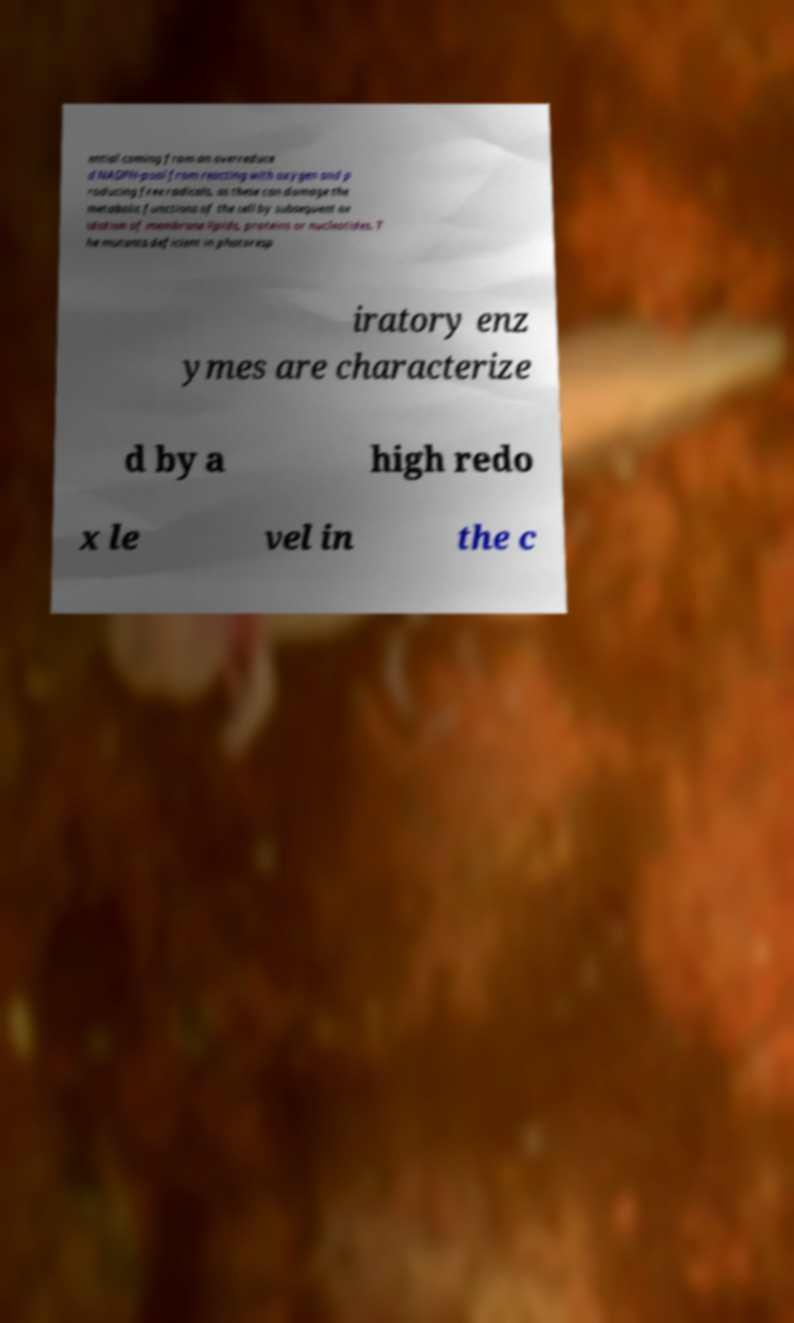Please identify and transcribe the text found in this image. ential coming from an overreduce d NADPH-pool from reacting with oxygen and p roducing free radicals, as these can damage the metabolic functions of the cell by subsequent ox idation of membrane lipids, proteins or nucleotides. T he mutants deficient in photoresp iratory enz ymes are characterize d by a high redo x le vel in the c 